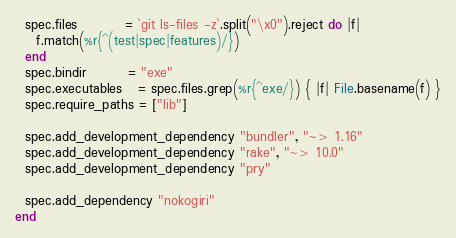<code> <loc_0><loc_0><loc_500><loc_500><_Ruby_>  spec.files         = `git ls-files -z`.split("\x0").reject do |f|
    f.match(%r{^(test|spec|features)/})
  end
  spec.bindir        = "exe"
  spec.executables   = spec.files.grep(%r{^exe/}) { |f| File.basename(f) }
  spec.require_paths = ["lib"]

  spec.add_development_dependency "bundler", "~> 1.16"
  spec.add_development_dependency "rake", "~> 10.0"
  spec.add_development_dependency "pry"

  spec.add_dependency "nokogiri"
end
</code> 